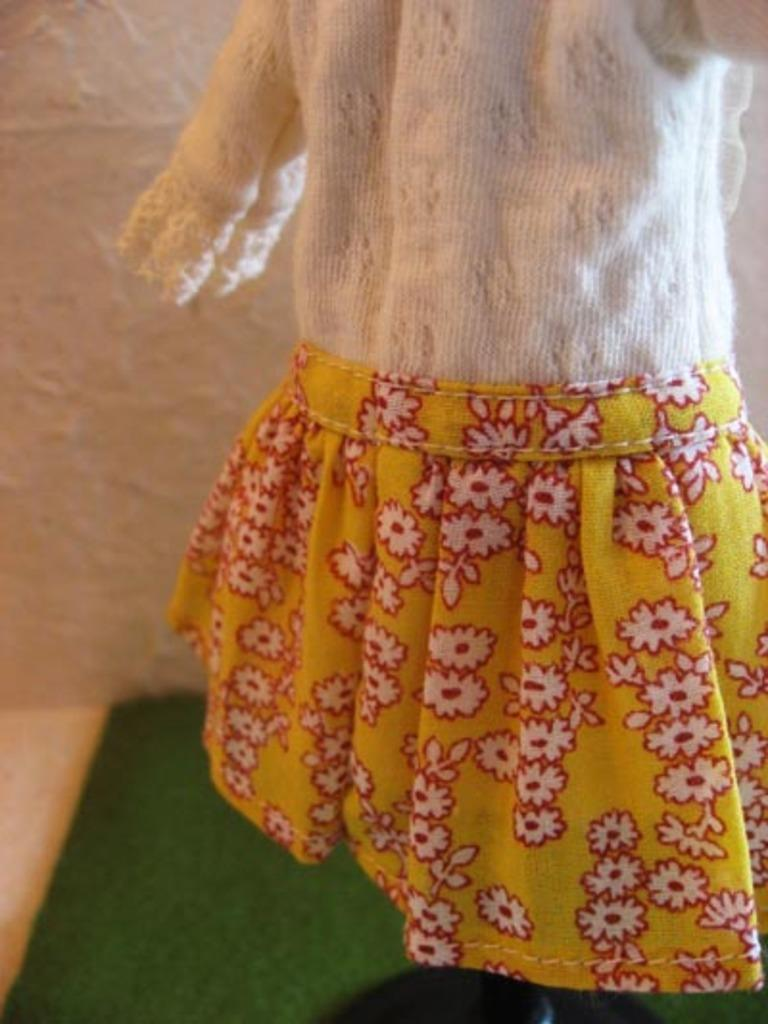What type of clothing is featured in the image? There is a dress in the image. What can be seen in the background of the image? There is a wall in the background of the image. What is located at the bottom of the image? There is a mat at the bottom of the image. How many boys are present at the party in the image? There is no party or boys present in the image; it only features a dress, a wall, and a mat. 